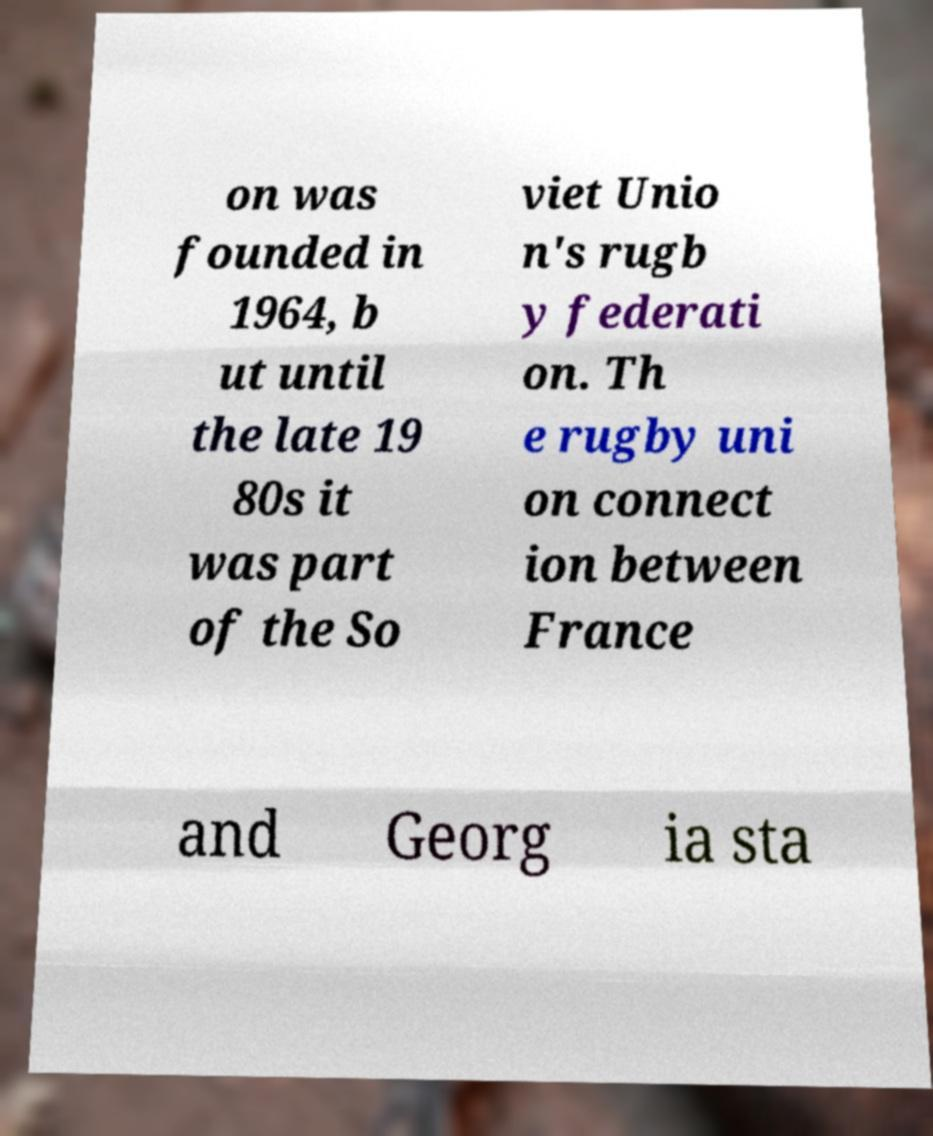For documentation purposes, I need the text within this image transcribed. Could you provide that? on was founded in 1964, b ut until the late 19 80s it was part of the So viet Unio n's rugb y federati on. Th e rugby uni on connect ion between France and Georg ia sta 